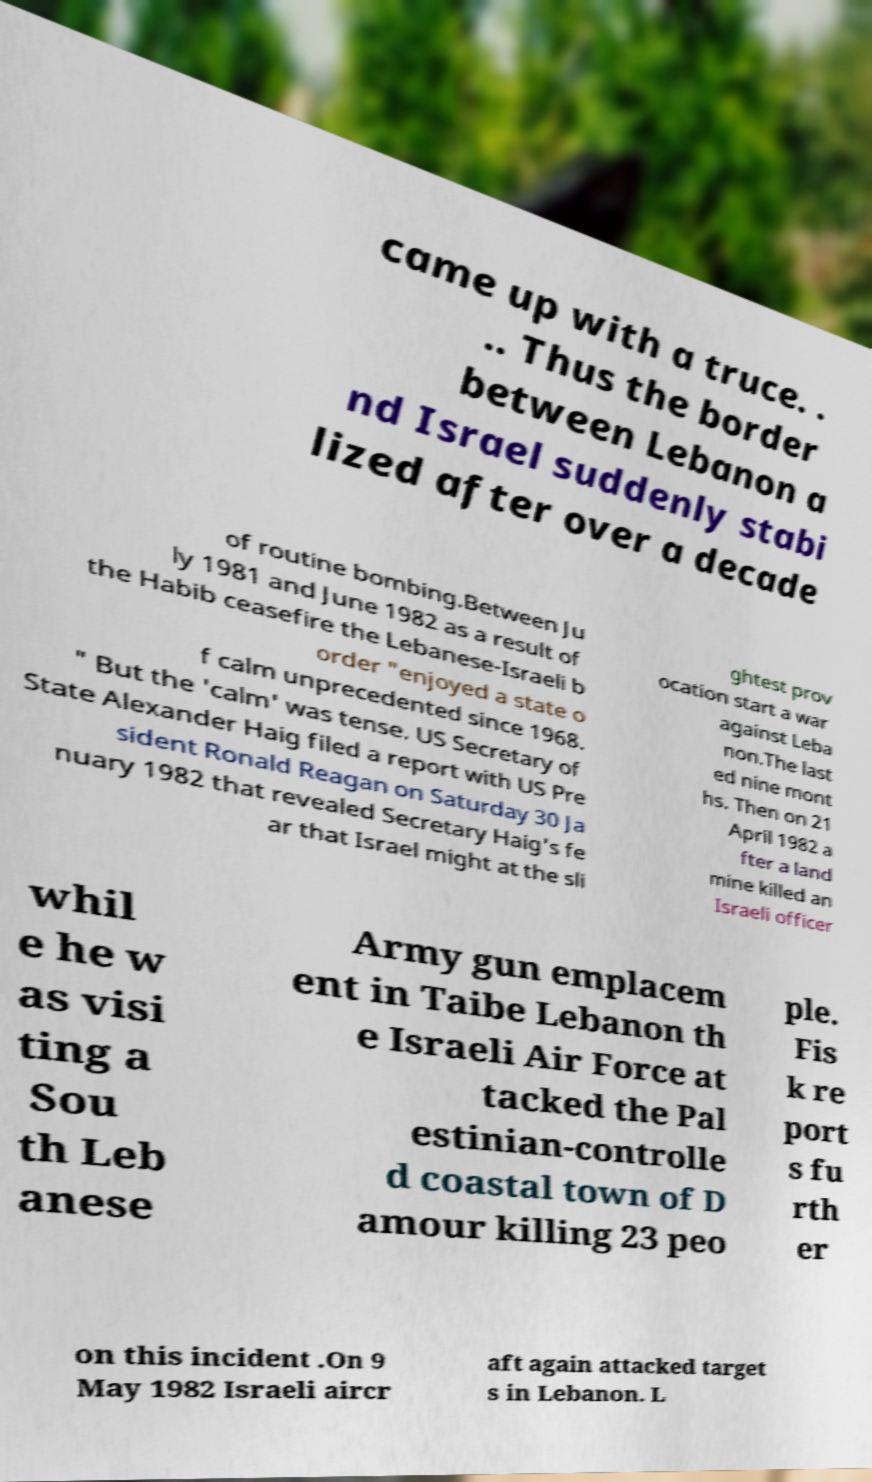I need the written content from this picture converted into text. Can you do that? came up with a truce. . .. Thus the border between Lebanon a nd Israel suddenly stabi lized after over a decade of routine bombing.Between Ju ly 1981 and June 1982 as a result of the Habib ceasefire the Lebanese-Israeli b order "enjoyed a state o f calm unprecedented since 1968. " But the 'calm' was tense. US Secretary of State Alexander Haig filed a report with US Pre sident Ronald Reagan on Saturday 30 Ja nuary 1982 that revealed Secretary Haig's fe ar that Israel might at the sli ghtest prov ocation start a war against Leba non.The last ed nine mont hs. Then on 21 April 1982 a fter a land mine killed an Israeli officer whil e he w as visi ting a Sou th Leb anese Army gun emplacem ent in Taibe Lebanon th e Israeli Air Force at tacked the Pal estinian-controlle d coastal town of D amour killing 23 peo ple. Fis k re port s fu rth er on this incident .On 9 May 1982 Israeli aircr aft again attacked target s in Lebanon. L 